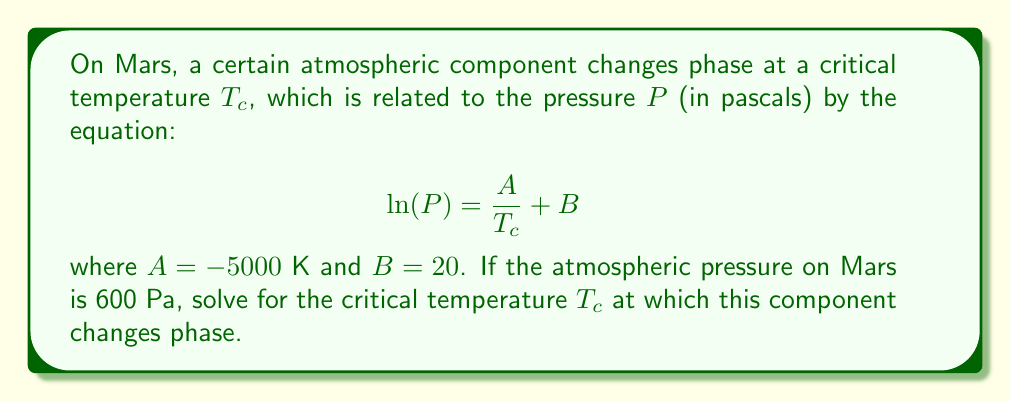Provide a solution to this math problem. To solve for the critical temperature $T_c$, we'll follow these steps:

1) We start with the given equation:
   $$\ln(P) = \frac{A}{T_c} + B$$

2) We know the values:
   $P = 600$ Pa
   $A = -5000$ K
   $B = 20$

3) Substitute these values into the equation:
   $$\ln(600) = \frac{-5000}{T_c} + 20$$

4) Simplify the left side:
   $$6.3969 = \frac{-5000}{T_c} + 20$$

5) Subtract 20 from both sides:
   $$-13.6031 = \frac{-5000}{T_c}$$

6) Multiply both sides by $T_c$:
   $$-13.6031T_c = -5000$$

7) Divide both sides by -13.6031:
   $$T_c = \frac{5000}{13.6031}$$

8) Calculate the final value:
   $$T_c \approx 367.56\text{ K}$$
Answer: $367.56\text{ K}$ 